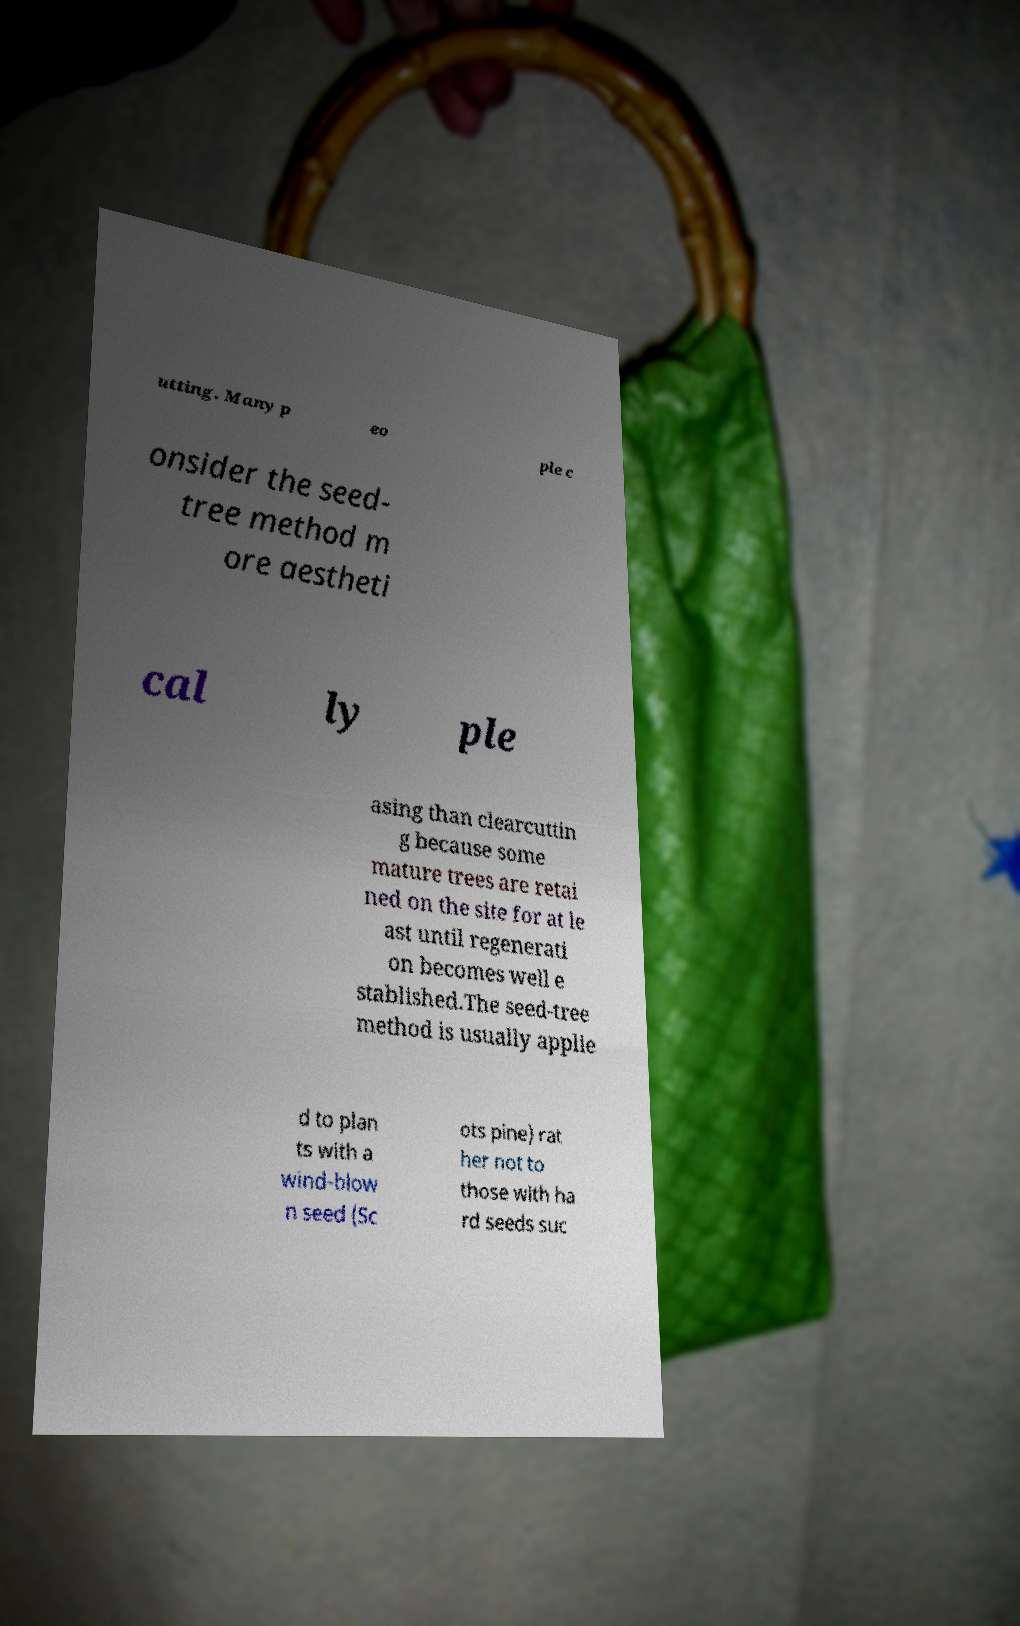I need the written content from this picture converted into text. Can you do that? utting. Many p eo ple c onsider the seed- tree method m ore aestheti cal ly ple asing than clearcuttin g because some mature trees are retai ned on the site for at le ast until regenerati on becomes well e stablished.The seed-tree method is usually applie d to plan ts with a wind-blow n seed (Sc ots pine) rat her not to those with ha rd seeds suc 